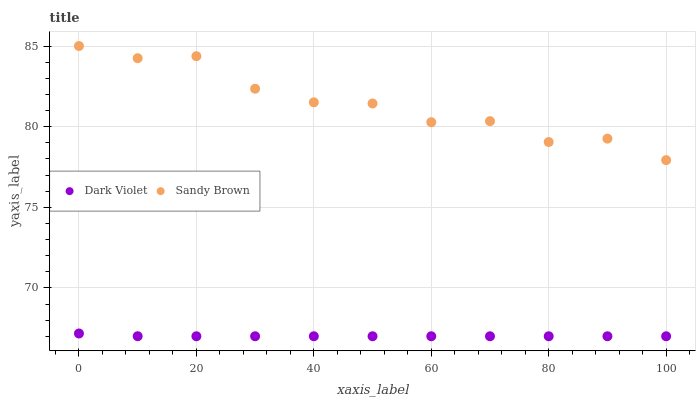Does Dark Violet have the minimum area under the curve?
Answer yes or no. Yes. Does Sandy Brown have the maximum area under the curve?
Answer yes or no. Yes. Does Dark Violet have the maximum area under the curve?
Answer yes or no. No. Is Dark Violet the smoothest?
Answer yes or no. Yes. Is Sandy Brown the roughest?
Answer yes or no. Yes. Is Dark Violet the roughest?
Answer yes or no. No. Does Dark Violet have the lowest value?
Answer yes or no. Yes. Does Sandy Brown have the highest value?
Answer yes or no. Yes. Does Dark Violet have the highest value?
Answer yes or no. No. Is Dark Violet less than Sandy Brown?
Answer yes or no. Yes. Is Sandy Brown greater than Dark Violet?
Answer yes or no. Yes. Does Dark Violet intersect Sandy Brown?
Answer yes or no. No. 